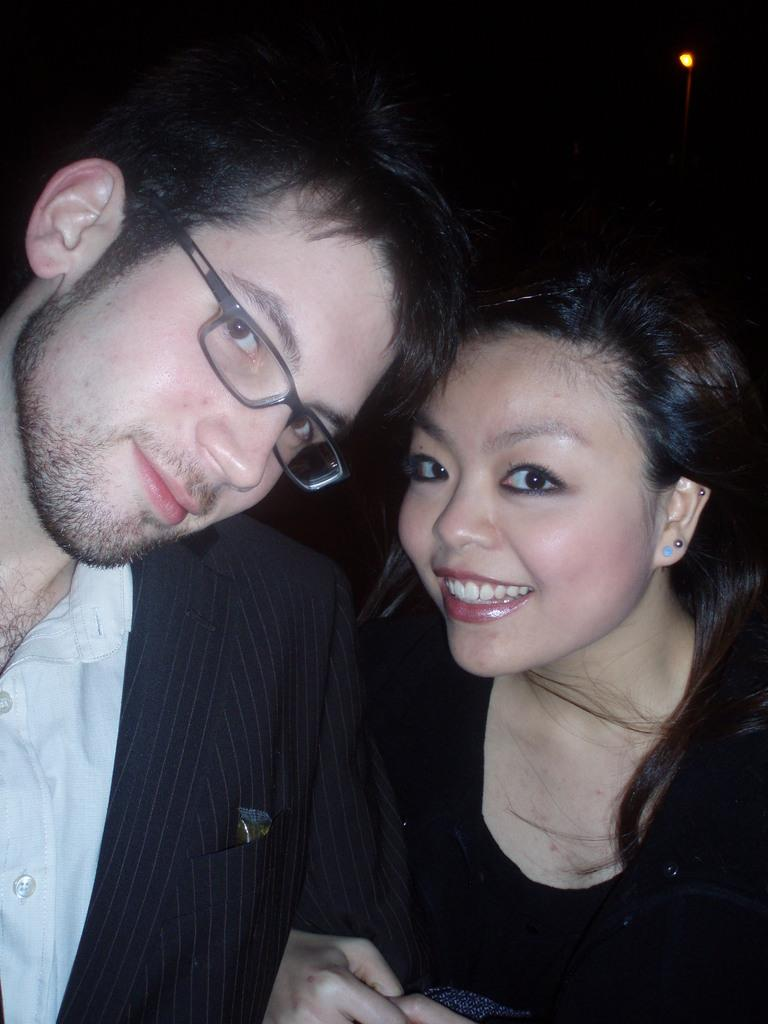How many people are in the image? There are two people in the image, a man and a woman. What are the expressions on their faces? Both the man and the woman are smiling in the image. Can you describe the man on the left side? The man on the left side is wearing spectacles. What can be seen in the background of the image? There is a light in the background of the image, and the background is dark. What type of authority figure is present in the image? There is no authority figure present in the image; it features a man and a woman smiling. Can you describe the condition of the man's toe in the image? There is no mention of the man's toe in the image, so it cannot be described. 